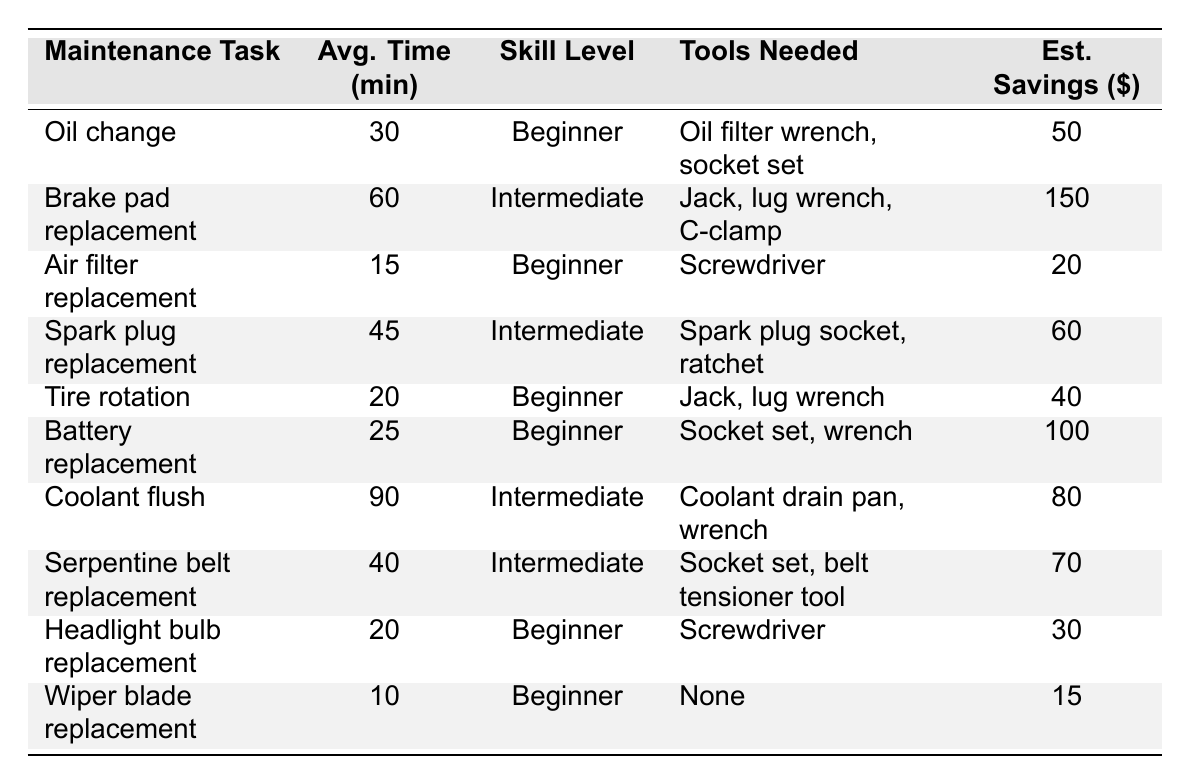What is the average time required for an oil change? The table shows that the average time required for an oil change is 30 minutes.
Answer: 30 minutes Which maintenance task takes the longest time to complete? According to the table, the coolant flush takes the longest time at 90 minutes.
Answer: Coolant flush How many tasks require an intermediate skill level? By counting the entries in the skill level column, there are 4 tasks that require an intermediate skill level (Brake pad replacement, Spark plug replacement, Coolant flush, Serpentine belt replacement).
Answer: 4 What tools are needed for spark plug replacement? The table lists the tools needed for spark plug replacement as a spark plug socket and a ratchet.
Answer: Spark plug socket, ratchet True or false: Wiper blade replacement is a task that requires an intermediate skill level. The skill level for wiper blade replacement is stated as beginner in the table. Therefore, the statement is false.
Answer: False What is the estimated cost savings for performing a tire rotation? The table displays an estimated cost savings of $40 for performing a tire rotation.
Answer: $40 If you only complete tasks that require a beginner skill level, what is the total average time required? The tasks that require a beginner skill level are: Oil change (30 min), Air filter replacement (15 min), Tire rotation (20 min), Battery replacement (25 min), Headlight bulb replacement (20 min), and Wiper blade replacement (10 min). Summing these gives: 30 + 15 + 20 + 25 + 20 + 10 = 130 minutes.
Answer: 130 minutes Which task has the highest estimated cost savings, and what is that amount? By checking the estimated savings, the highest amount is $150 for Brake pad replacement.
Answer: $150 How much time does it take to replace headlight bulbs compared to changing oil? Headlight bulb replacement takes 20 minutes, while an oil change takes 30 minutes. The difference is 30 - 20 = 10 minutes, meaning replacing headlight bulbs is faster by 10 minutes.
Answer: 10 minutes What is the average savings for maintenance tasks that require beginner skill level? The savings for beginner tasks are: $50 (Oil change), $20 (Air filter replacement), $40 (Tire rotation), $100 (Battery replacement), $30 (Headlight bulb replacement), and $15 (Wiper blade replacement). Summing these gives: 50 + 20 + 40 + 100 + 30 + 15 = 255. There are 6 tasks, so the average savings is 255/6 = 42.5.
Answer: $42.5 